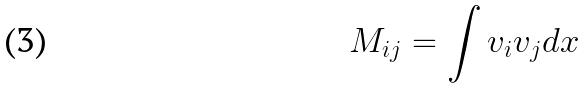Convert formula to latex. <formula><loc_0><loc_0><loc_500><loc_500>M _ { i j } = \int v _ { i } v _ { j } d x</formula> 